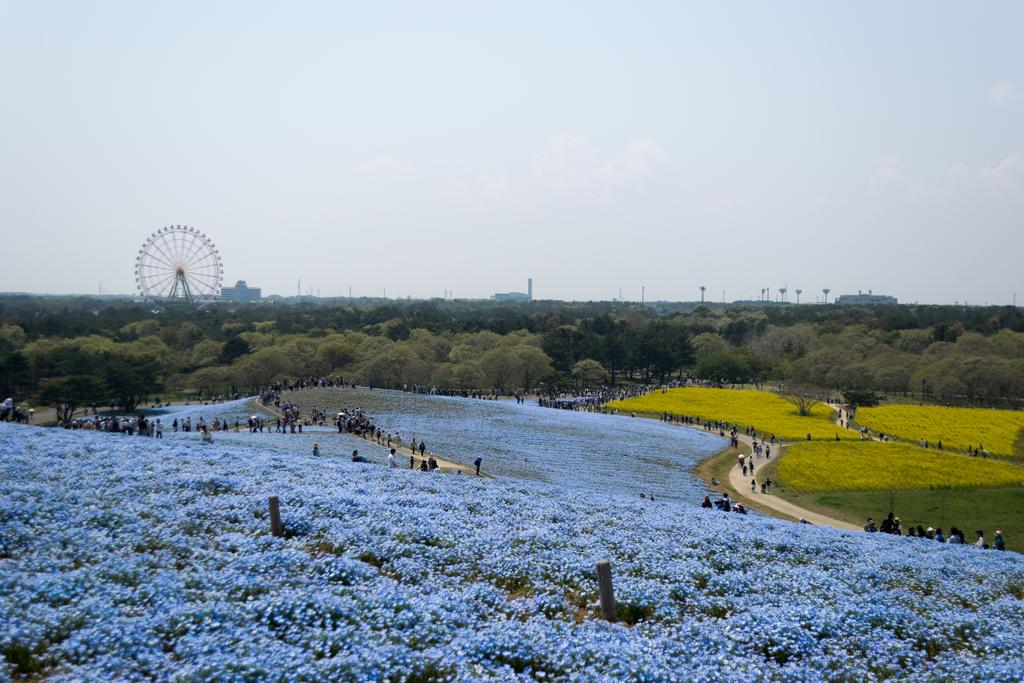What type of vegetation can be seen in the image? There are plants, flowers, and trees in the image. What is the ground covered with in the image? There is grass in the image. What is the circular object in the image? There is a joint wheel in the image. Who or what is present in the image? There are people in the image. What can be seen in the background of the image? There are buildings and sky visible in the background of the image. What type of attraction can be seen in the image? There is no attraction present in the image; it features plants, flowers, trees, grass, a joint wheel, people, buildings, and sky. What does the dad in the image say about the rainstorm? There is no dad or rainstorm mentioned in the image. 